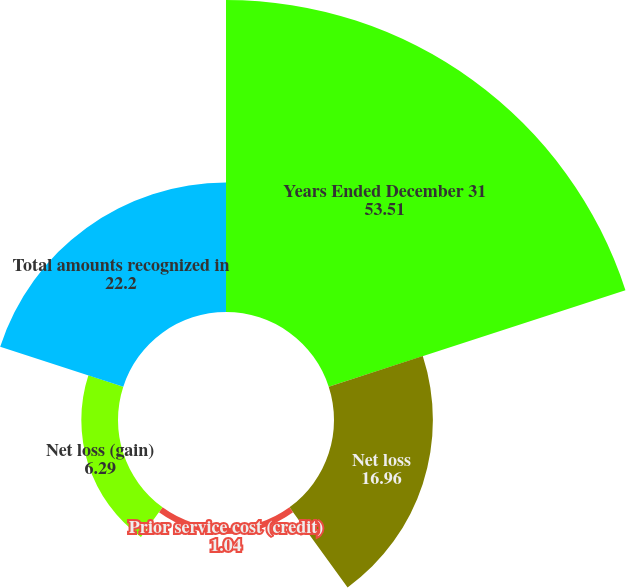Convert chart to OTSL. <chart><loc_0><loc_0><loc_500><loc_500><pie_chart><fcel>Years Ended December 31<fcel>Net loss<fcel>Prior service cost (credit)<fcel>Net loss (gain)<fcel>Total amounts recognized in<nl><fcel>53.51%<fcel>16.96%<fcel>1.04%<fcel>6.29%<fcel>22.2%<nl></chart> 